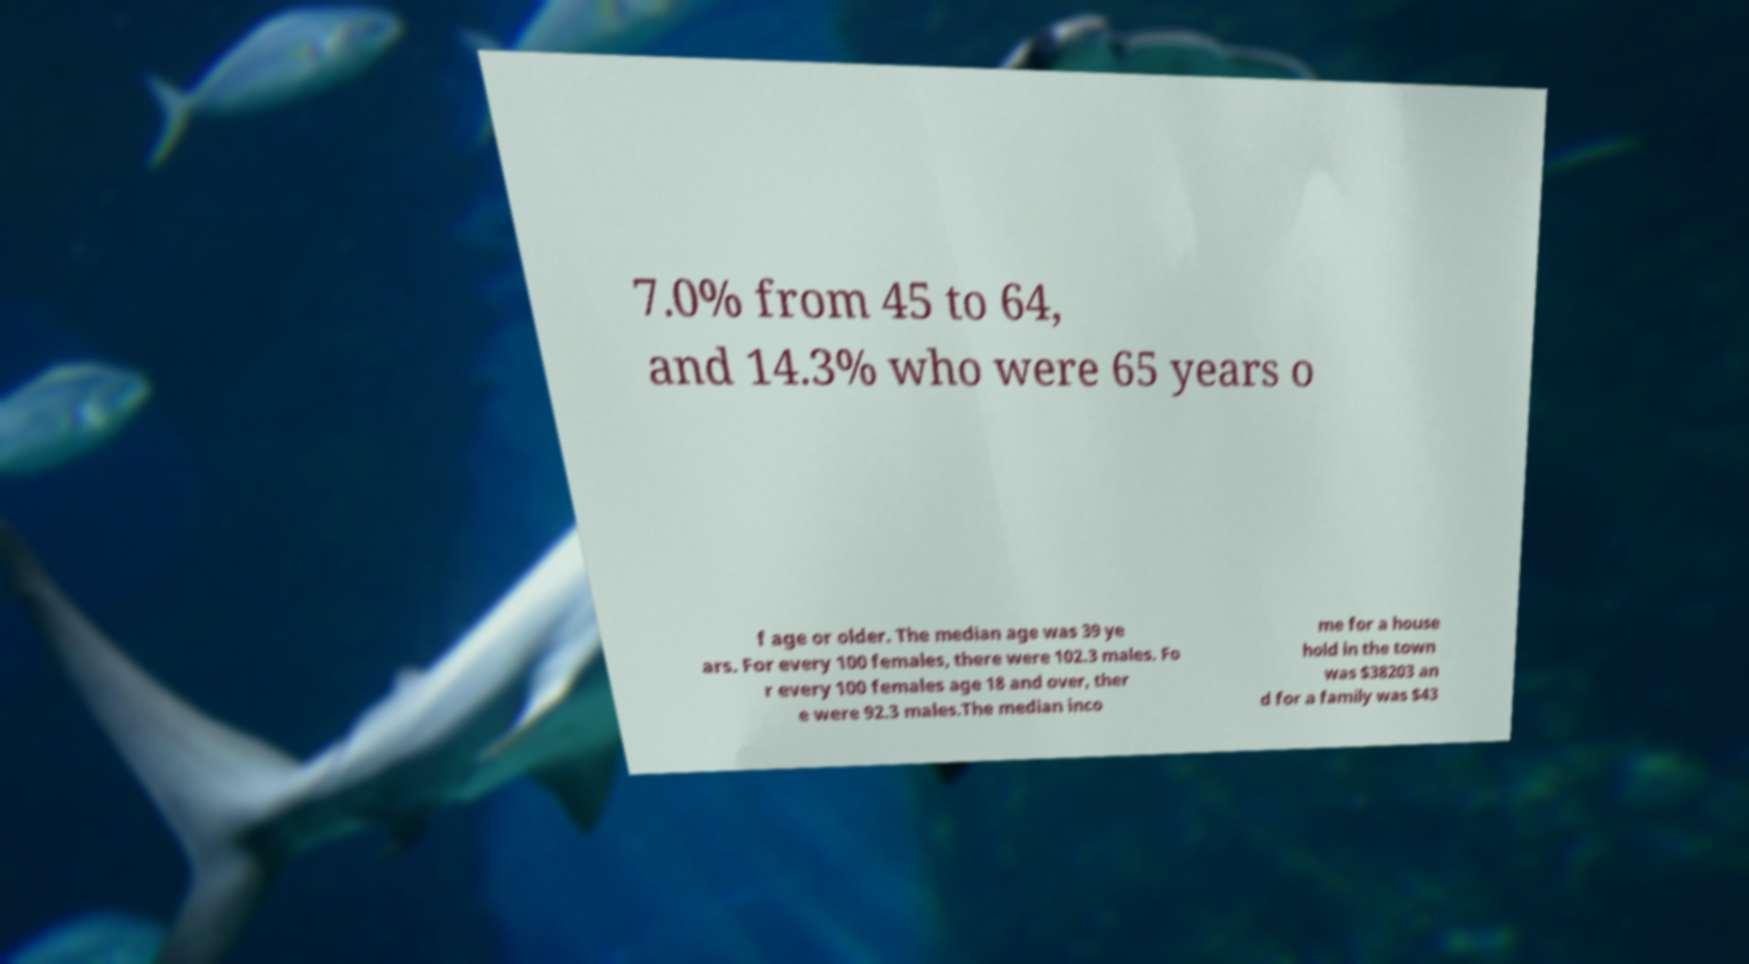What messages or text are displayed in this image? I need them in a readable, typed format. 7.0% from 45 to 64, and 14.3% who were 65 years o f age or older. The median age was 39 ye ars. For every 100 females, there were 102.3 males. Fo r every 100 females age 18 and over, ther e were 92.3 males.The median inco me for a house hold in the town was $38203 an d for a family was $43 